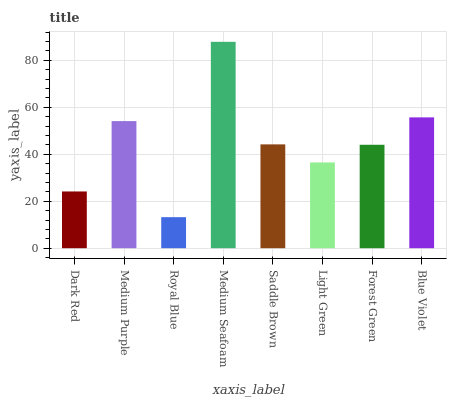Is Royal Blue the minimum?
Answer yes or no. Yes. Is Medium Seafoam the maximum?
Answer yes or no. Yes. Is Medium Purple the minimum?
Answer yes or no. No. Is Medium Purple the maximum?
Answer yes or no. No. Is Medium Purple greater than Dark Red?
Answer yes or no. Yes. Is Dark Red less than Medium Purple?
Answer yes or no. Yes. Is Dark Red greater than Medium Purple?
Answer yes or no. No. Is Medium Purple less than Dark Red?
Answer yes or no. No. Is Saddle Brown the high median?
Answer yes or no. Yes. Is Forest Green the low median?
Answer yes or no. Yes. Is Dark Red the high median?
Answer yes or no. No. Is Dark Red the low median?
Answer yes or no. No. 